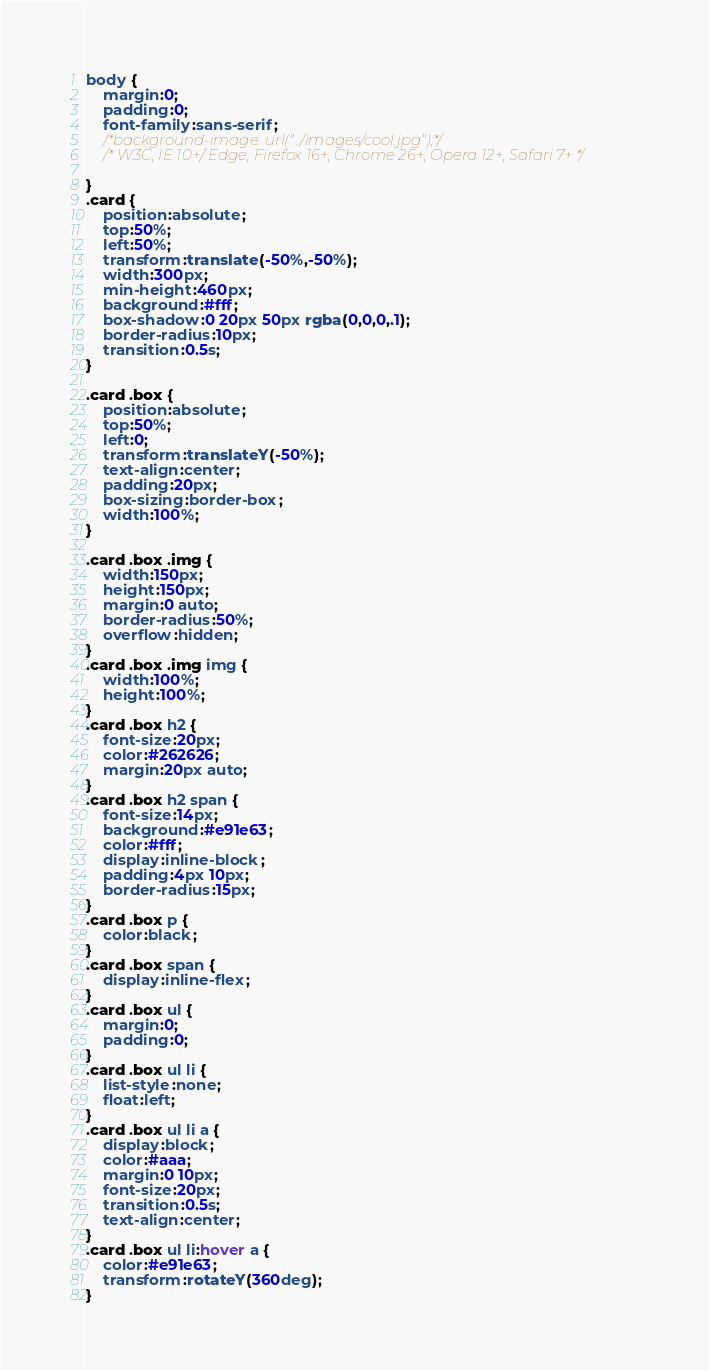<code> <loc_0><loc_0><loc_500><loc_500><_CSS_>body {
    margin:0;
    padding:0;
    font-family:sans-serif;
    /*background-image: url("../images/cool.jpg");*/
    /* W3C, IE 10+/ Edge, Firefox 16+, Chrome 26+, Opera 12+, Safari 7+ */
    
}
.card {
    position:absolute;
    top:50%;
    left:50%;
    transform:translate(-50%,-50%);
    width:300px;
    min-height:460px;
    background:#fff;
    box-shadow:0 20px 50px rgba(0,0,0,.1);
    border-radius:10px;
    transition:0.5s;
}

.card .box {
    position:absolute;
    top:50%;
    left:0;
    transform:translateY(-50%);
    text-align:center;
    padding:20px;
    box-sizing:border-box;
    width:100%;
}

.card .box .img {
    width:150px;
    height:150px;
    margin:0 auto;
    border-radius:50%;
    overflow:hidden;
}
.card .box .img img {
    width:100%;
    height:100%;
}
.card .box h2 {
    font-size:20px;
    color:#262626;
    margin:20px auto;
}
.card .box h2 span {
    font-size:14px;
    background:#e91e63;
    color:#fff;
    display:inline-block;
    padding:4px 10px;
    border-radius:15px;
}
.card .box p {
    color:black;
}
.card .box span {
    display:inline-flex;
}
.card .box ul {
    margin:0;
    padding:0;
}
.card .box ul li {
    list-style:none;
    float:left;
}
.card .box ul li a {
    display:block;
    color:#aaa;
    margin:0 10px;
    font-size:20px;
    transition:0.5s;
    text-align:center;
}
.card .box ul li:hover a {
    color:#e91e63;
    transform:rotateY(360deg);
}</code> 